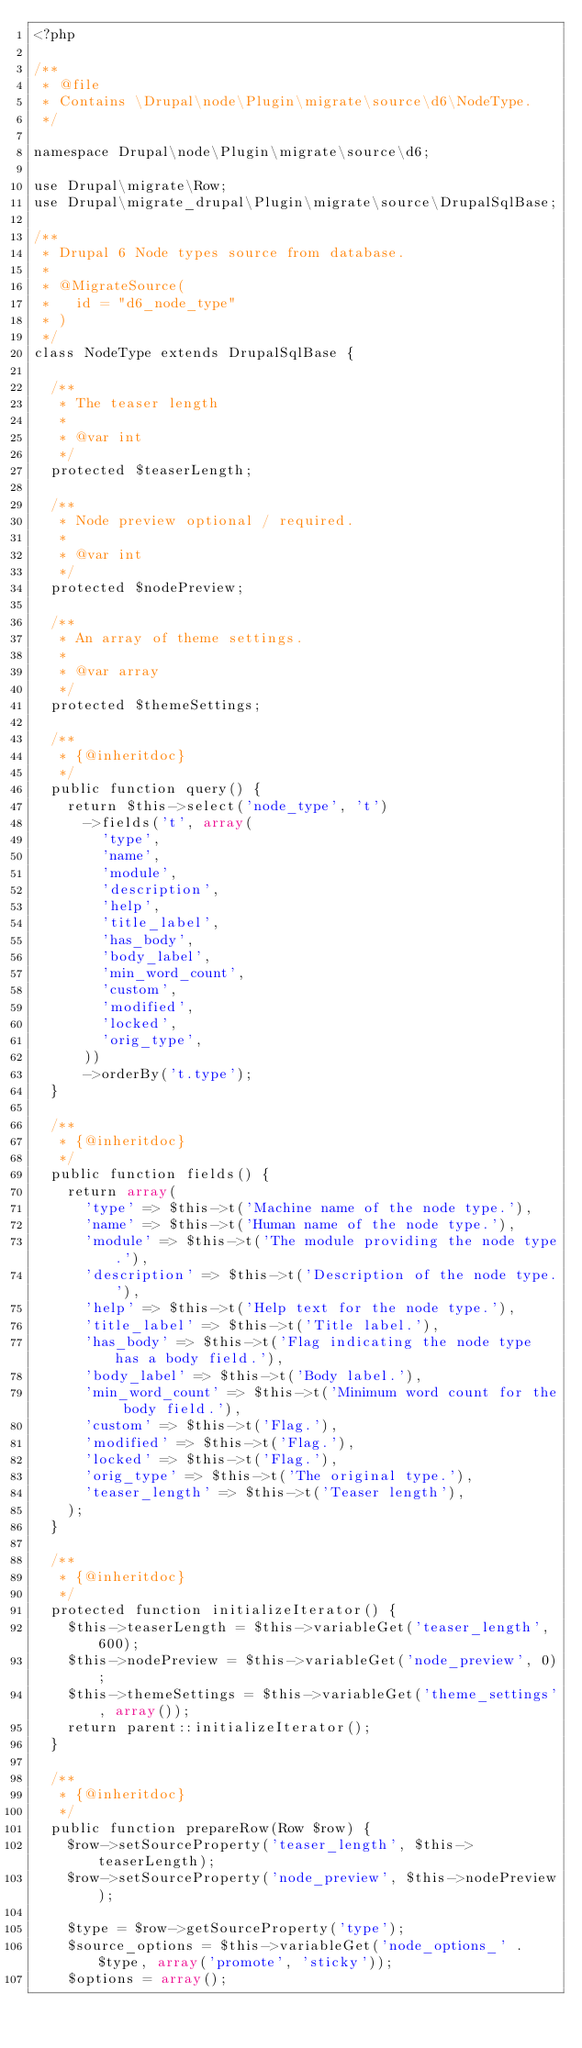Convert code to text. <code><loc_0><loc_0><loc_500><loc_500><_PHP_><?php

/**
 * @file
 * Contains \Drupal\node\Plugin\migrate\source\d6\NodeType.
 */

namespace Drupal\node\Plugin\migrate\source\d6;

use Drupal\migrate\Row;
use Drupal\migrate_drupal\Plugin\migrate\source\DrupalSqlBase;

/**
 * Drupal 6 Node types source from database.
 *
 * @MigrateSource(
 *   id = "d6_node_type"
 * )
 */
class NodeType extends DrupalSqlBase {

  /**
   * The teaser length
   *
   * @var int
   */
  protected $teaserLength;

  /**
   * Node preview optional / required.
   *
   * @var int
   */
  protected $nodePreview;

  /**
   * An array of theme settings.
   *
   * @var array
   */
  protected $themeSettings;

  /**
   * {@inheritdoc}
   */
  public function query() {
    return $this->select('node_type', 't')
      ->fields('t', array(
        'type',
        'name',
        'module',
        'description',
        'help',
        'title_label',
        'has_body',
        'body_label',
        'min_word_count',
        'custom',
        'modified',
        'locked',
        'orig_type',
      ))
      ->orderBy('t.type');
  }

  /**
   * {@inheritdoc}
   */
  public function fields() {
    return array(
      'type' => $this->t('Machine name of the node type.'),
      'name' => $this->t('Human name of the node type.'),
      'module' => $this->t('The module providing the node type.'),
      'description' => $this->t('Description of the node type.'),
      'help' => $this->t('Help text for the node type.'),
      'title_label' => $this->t('Title label.'),
      'has_body' => $this->t('Flag indicating the node type has a body field.'),
      'body_label' => $this->t('Body label.'),
      'min_word_count' => $this->t('Minimum word count for the body field.'),
      'custom' => $this->t('Flag.'),
      'modified' => $this->t('Flag.'),
      'locked' => $this->t('Flag.'),
      'orig_type' => $this->t('The original type.'),
      'teaser_length' => $this->t('Teaser length'),
    );
  }

  /**
   * {@inheritdoc}
   */
  protected function initializeIterator() {
    $this->teaserLength = $this->variableGet('teaser_length', 600);
    $this->nodePreview = $this->variableGet('node_preview', 0);
    $this->themeSettings = $this->variableGet('theme_settings', array());
    return parent::initializeIterator();
  }

  /**
   * {@inheritdoc}
   */
  public function prepareRow(Row $row) {
    $row->setSourceProperty('teaser_length', $this->teaserLength);
    $row->setSourceProperty('node_preview', $this->nodePreview);

    $type = $row->getSourceProperty('type');
    $source_options = $this->variableGet('node_options_' . $type, array('promote', 'sticky'));
    $options = array();</code> 